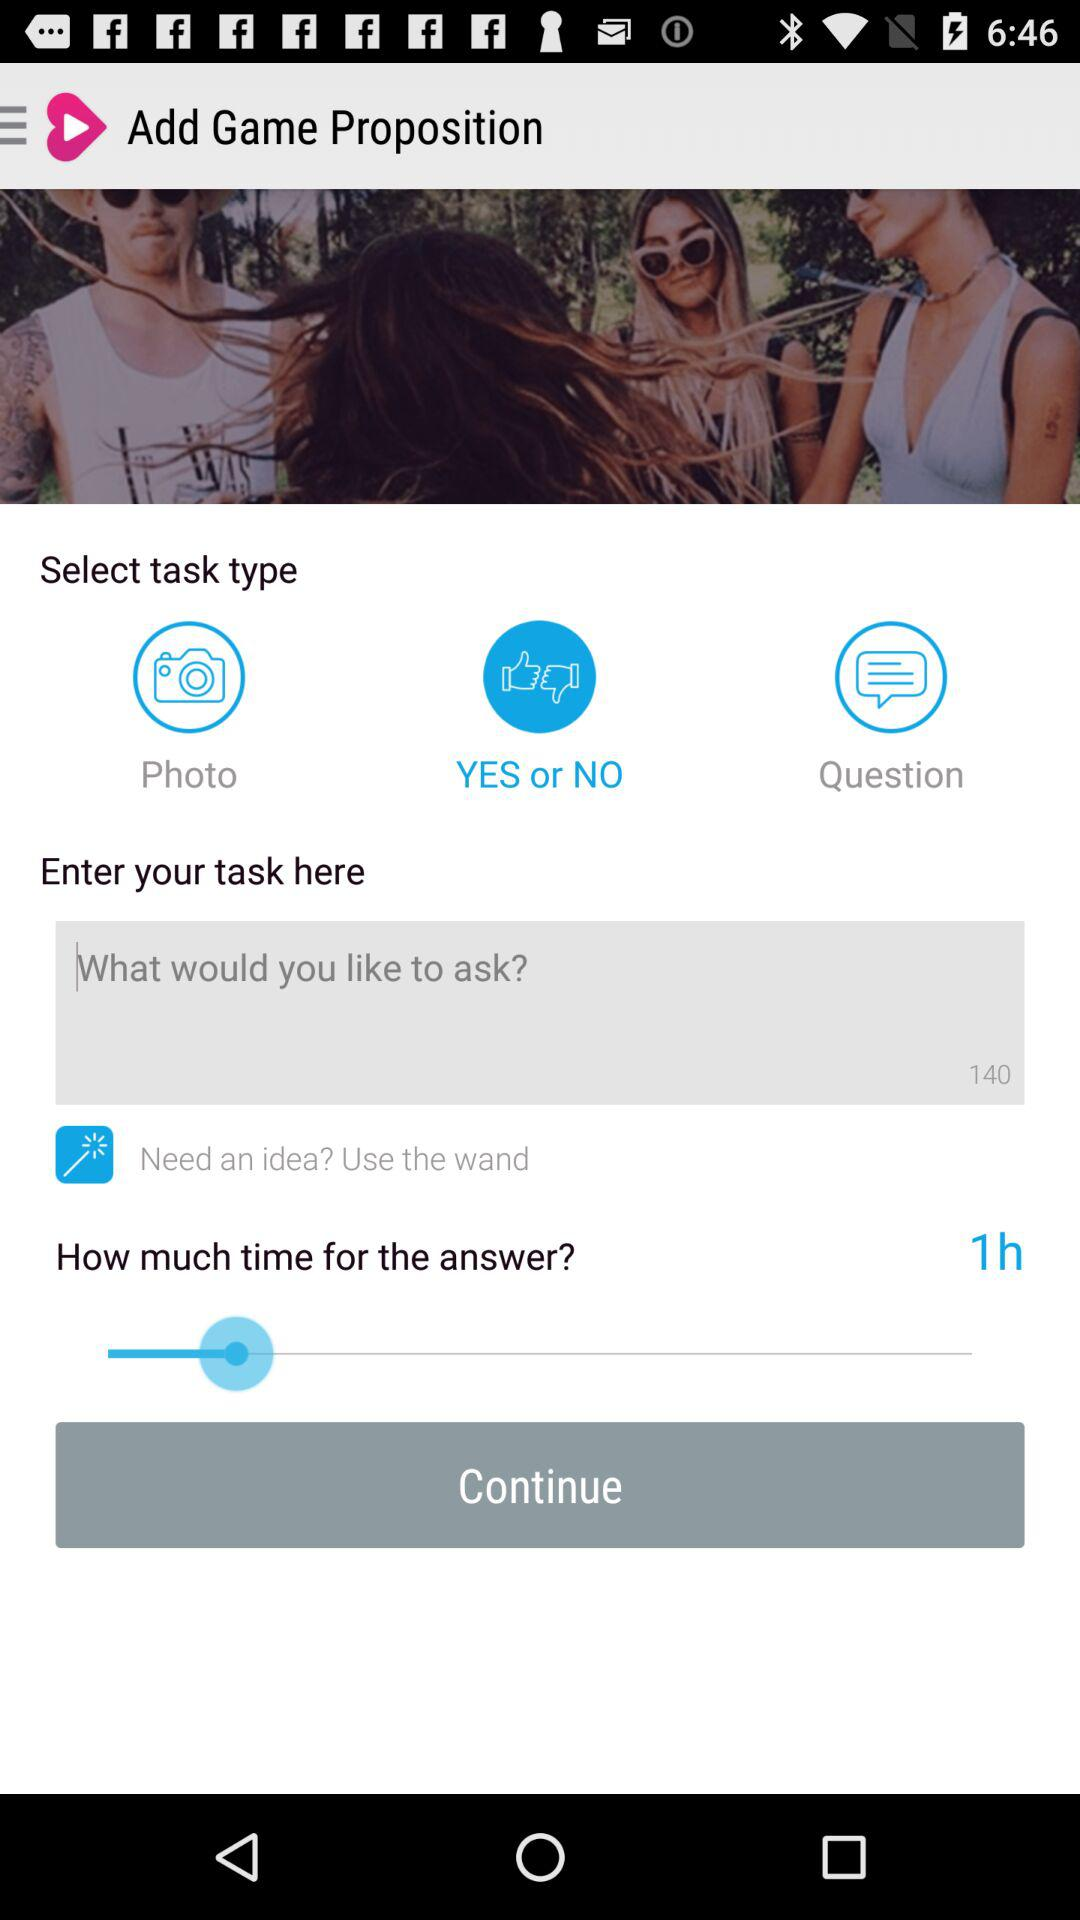What is the set duration for the answer? The set duration for the answer is 1 hour. 